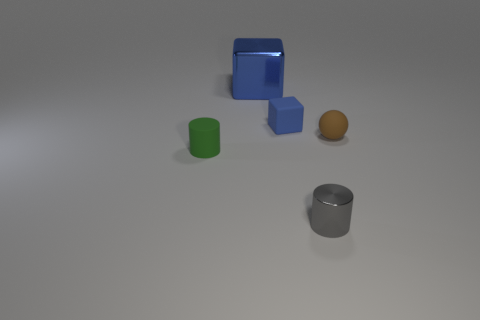Add 3 rubber objects. How many objects exist? 8 Subtract all cubes. How many objects are left? 3 Subtract all tiny metallic objects. Subtract all big gray metallic cylinders. How many objects are left? 4 Add 2 metal blocks. How many metal blocks are left? 3 Add 1 green objects. How many green objects exist? 2 Subtract 0 red blocks. How many objects are left? 5 Subtract all cyan cylinders. Subtract all yellow cubes. How many cylinders are left? 2 